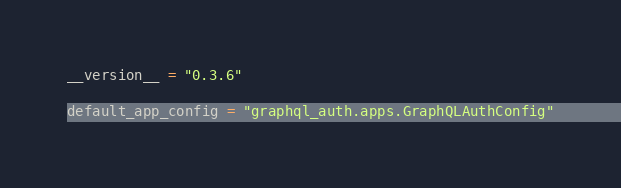<code> <loc_0><loc_0><loc_500><loc_500><_Python_>__version__ = "0.3.6"

default_app_config = "graphql_auth.apps.GraphQLAuthConfig"
</code> 